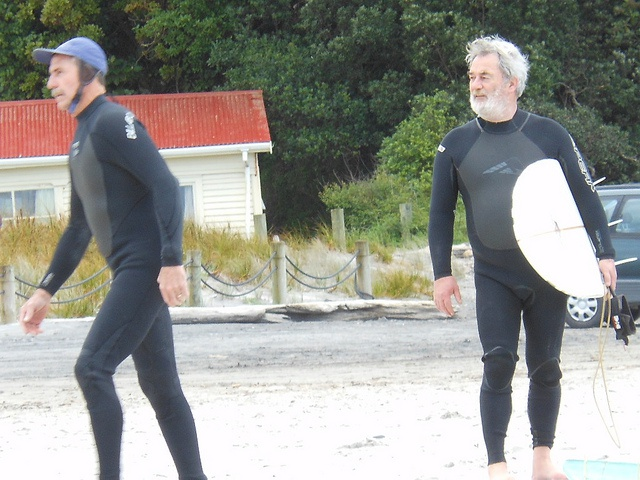Describe the objects in this image and their specific colors. I can see people in darkgreen, gray, black, and tan tones, people in darkgreen, gray, lightgray, and black tones, surfboard in darkgreen, white, darkgray, and gray tones, and car in darkgreen, gray, darkgray, and lightgray tones in this image. 